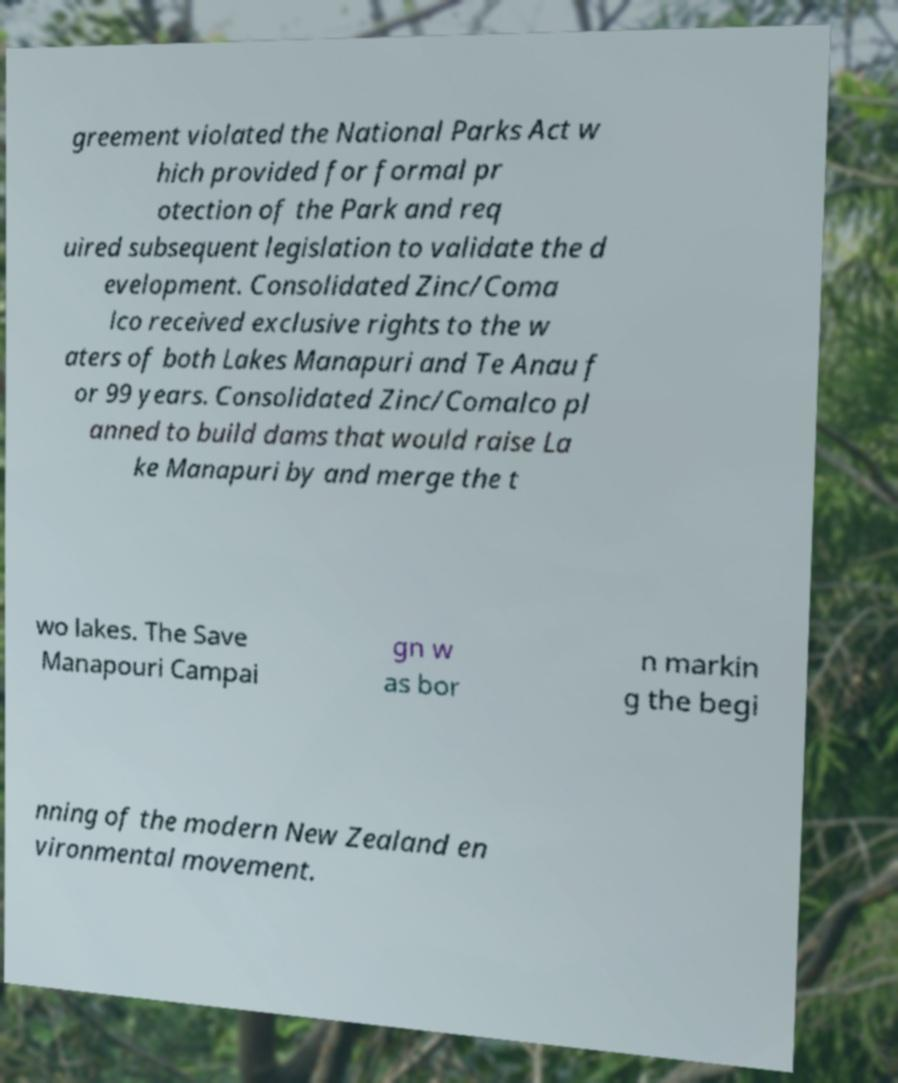What messages or text are displayed in this image? I need them in a readable, typed format. greement violated the National Parks Act w hich provided for formal pr otection of the Park and req uired subsequent legislation to validate the d evelopment. Consolidated Zinc/Coma lco received exclusive rights to the w aters of both Lakes Manapuri and Te Anau f or 99 years. Consolidated Zinc/Comalco pl anned to build dams that would raise La ke Manapuri by and merge the t wo lakes. The Save Manapouri Campai gn w as bor n markin g the begi nning of the modern New Zealand en vironmental movement. 